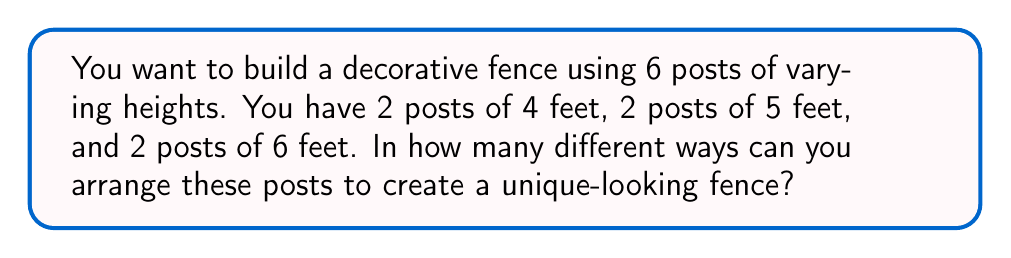What is the answer to this math problem? Let's approach this step-by-step:

1) This is a permutation problem with repeated elements. We have:
   - 2 posts of 4 feet
   - 2 posts of 5 feet
   - 2 posts of 6 feet

2) The total number of posts is 6.

3) If all posts were different, we would have 6! arrangements. However, we have repeats, so we need to account for these.

4) For each type of post, we have 2! ways to arrange them among themselves. This arrangement doesn't create a new overall arrangement.

5) We need to divide the total number of permutations by the number of permutations for each repeated element:

   $$\text{Number of arrangements} = \frac{6!}{(2!)(2!)(2!)}$$

6) Let's calculate this:
   $$\frac{6!}{(2!)(2!)(2!)} = \frac{6 \times 5 \times 4 \times 3 \times 2 \times 1}{(2 \times 1)(2 \times 1)(2 \times 1)}$$
   
   $$= \frac{720}{8} = 90$$

Therefore, there are 90 different ways to arrange the fence posts.
Answer: 90 